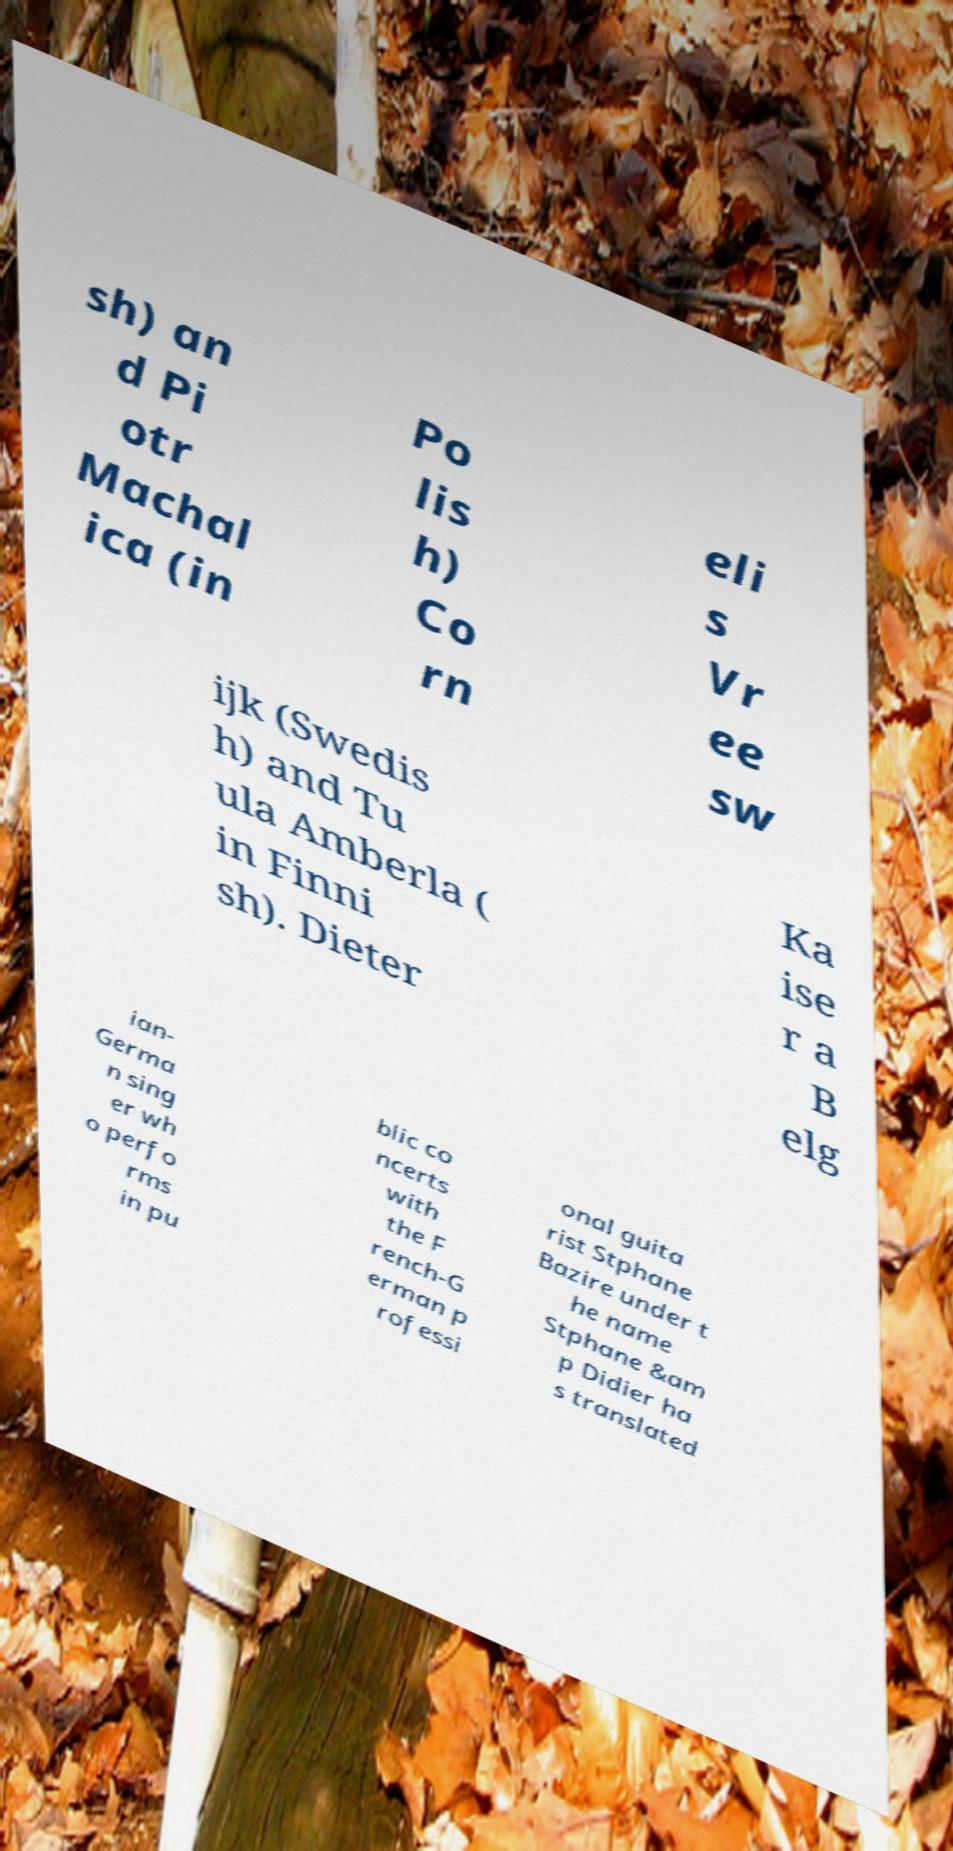Please identify and transcribe the text found in this image. sh) an d Pi otr Machal ica (in Po lis h) Co rn eli s Vr ee sw ijk (Swedis h) and Tu ula Amberla ( in Finni sh). Dieter Ka ise r a B elg ian- Germa n sing er wh o perfo rms in pu blic co ncerts with the F rench-G erman p rofessi onal guita rist Stphane Bazire under t he name Stphane &am p Didier ha s translated 